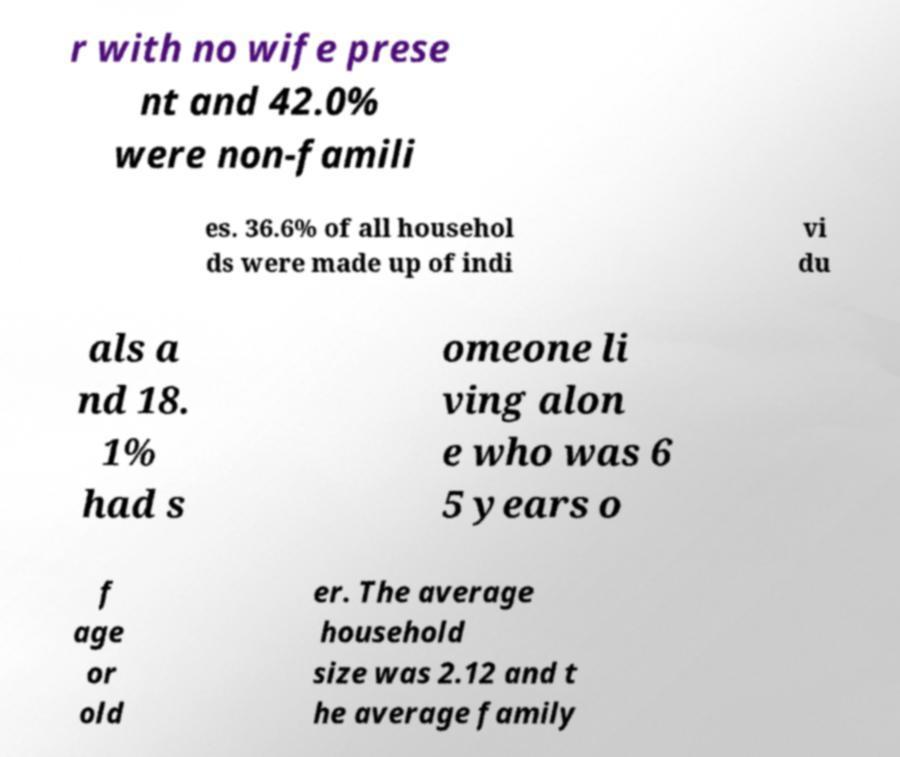What messages or text are displayed in this image? I need them in a readable, typed format. r with no wife prese nt and 42.0% were non-famili es. 36.6% of all househol ds were made up of indi vi du als a nd 18. 1% had s omeone li ving alon e who was 6 5 years o f age or old er. The average household size was 2.12 and t he average family 